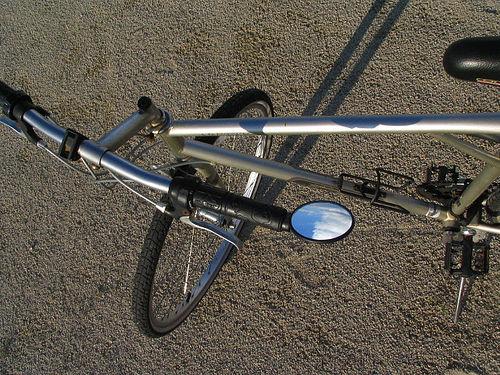How many wheels does this have?
Answer briefly. 2. Is this bicycle casting a shadow?
Answer briefly. Yes. Where is a mirror?
Quick response, please. Handlebar. 